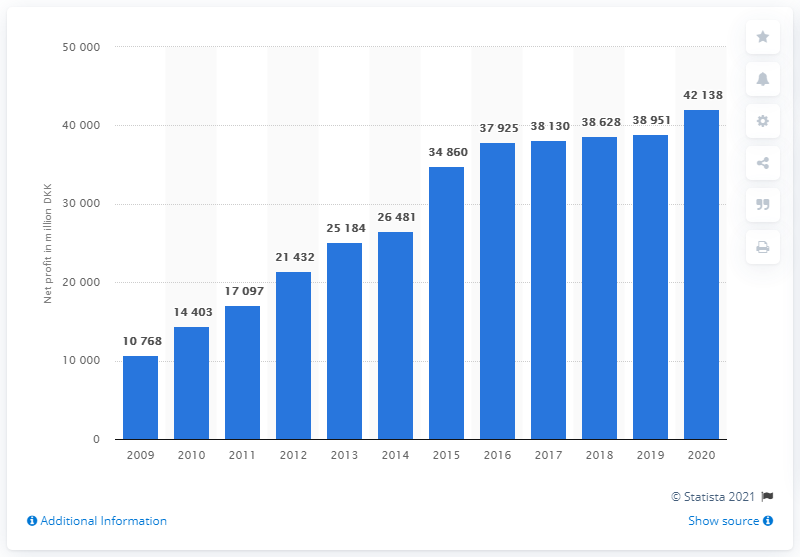Identify some key points in this picture. In 2020, Novo Nordisk's net profit was 42,138. 